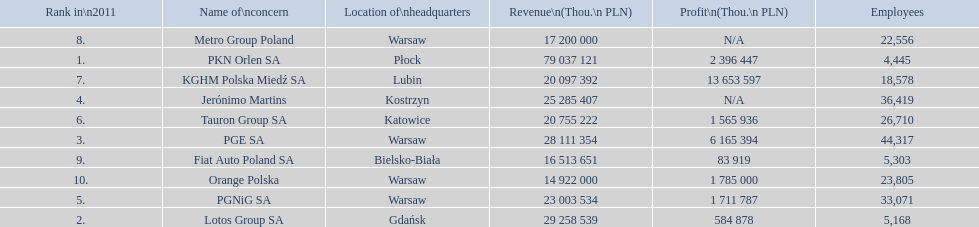Which company had the least revenue? Orange Polska. 